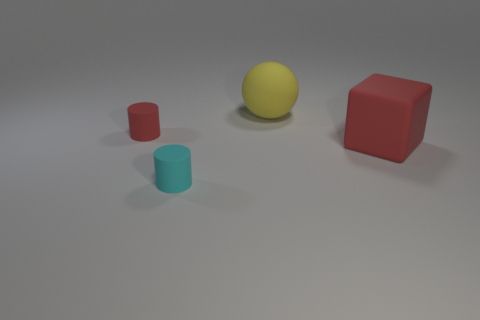Add 4 red matte cylinders. How many objects exist? 8 Subtract all balls. How many objects are left? 3 Subtract 1 cubes. How many cubes are left? 0 Subtract all green cylinders. How many green balls are left? 0 Subtract all tiny matte things. Subtract all cyan rubber cylinders. How many objects are left? 1 Add 2 big matte balls. How many big matte balls are left? 3 Add 2 gray rubber things. How many gray rubber things exist? 2 Subtract 1 red cylinders. How many objects are left? 3 Subtract all blue balls. Subtract all purple blocks. How many balls are left? 1 